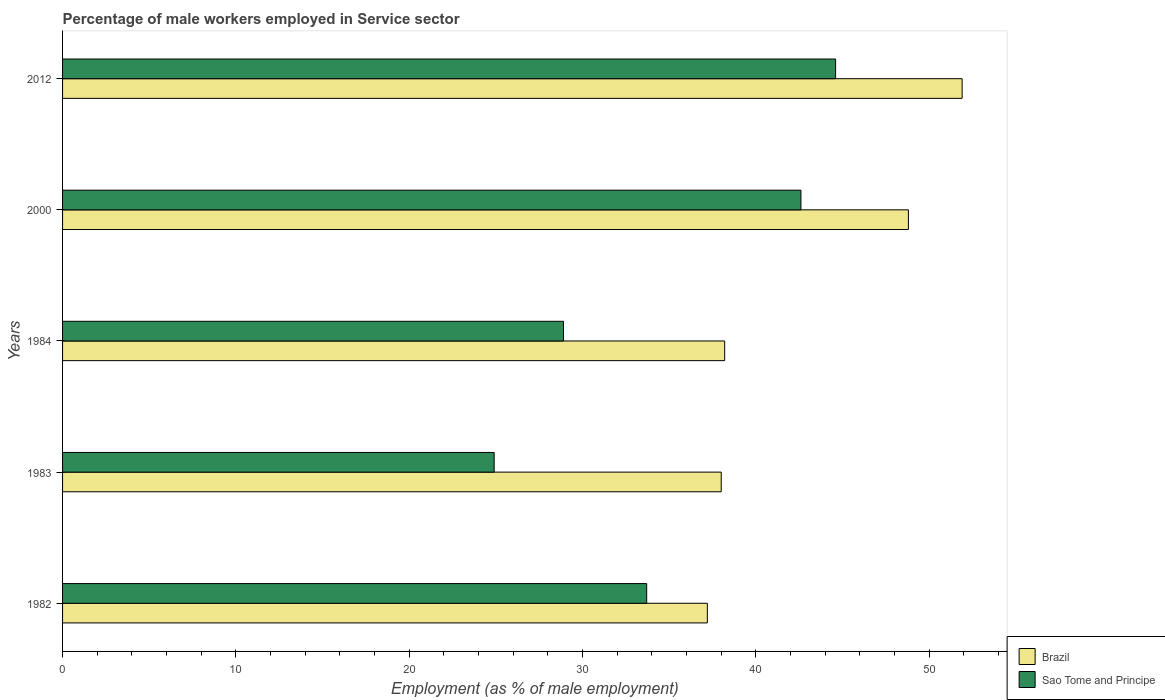Are the number of bars on each tick of the Y-axis equal?
Offer a very short reply. Yes. How many bars are there on the 4th tick from the top?
Your answer should be compact. 2. What is the label of the 1st group of bars from the top?
Provide a short and direct response. 2012. In how many cases, is the number of bars for a given year not equal to the number of legend labels?
Offer a very short reply. 0. What is the percentage of male workers employed in Service sector in Sao Tome and Principe in 2012?
Offer a very short reply. 44.6. Across all years, what is the maximum percentage of male workers employed in Service sector in Brazil?
Your response must be concise. 51.9. Across all years, what is the minimum percentage of male workers employed in Service sector in Sao Tome and Principe?
Provide a succinct answer. 24.9. In which year was the percentage of male workers employed in Service sector in Brazil maximum?
Provide a succinct answer. 2012. What is the total percentage of male workers employed in Service sector in Sao Tome and Principe in the graph?
Provide a short and direct response. 174.7. What is the difference between the percentage of male workers employed in Service sector in Brazil in 1982 and that in 2012?
Your response must be concise. -14.7. What is the difference between the percentage of male workers employed in Service sector in Brazil in 1983 and the percentage of male workers employed in Service sector in Sao Tome and Principe in 2012?
Your answer should be very brief. -6.6. What is the average percentage of male workers employed in Service sector in Sao Tome and Principe per year?
Keep it short and to the point. 34.94. In the year 1984, what is the difference between the percentage of male workers employed in Service sector in Brazil and percentage of male workers employed in Service sector in Sao Tome and Principe?
Give a very brief answer. 9.3. In how many years, is the percentage of male workers employed in Service sector in Sao Tome and Principe greater than 10 %?
Your answer should be compact. 5. What is the ratio of the percentage of male workers employed in Service sector in Brazil in 1984 to that in 2012?
Provide a short and direct response. 0.74. Is the difference between the percentage of male workers employed in Service sector in Brazil in 1984 and 2012 greater than the difference between the percentage of male workers employed in Service sector in Sao Tome and Principe in 1984 and 2012?
Offer a very short reply. Yes. What is the difference between the highest and the second highest percentage of male workers employed in Service sector in Brazil?
Your response must be concise. 3.1. What is the difference between the highest and the lowest percentage of male workers employed in Service sector in Brazil?
Your answer should be compact. 14.7. Is the sum of the percentage of male workers employed in Service sector in Sao Tome and Principe in 1982 and 1983 greater than the maximum percentage of male workers employed in Service sector in Brazil across all years?
Keep it short and to the point. Yes. What does the 1st bar from the top in 2012 represents?
Your answer should be compact. Sao Tome and Principe. What does the 1st bar from the bottom in 1982 represents?
Offer a terse response. Brazil. How many bars are there?
Give a very brief answer. 10. What is the difference between two consecutive major ticks on the X-axis?
Make the answer very short. 10. Does the graph contain grids?
Your answer should be compact. No. How many legend labels are there?
Your response must be concise. 2. What is the title of the graph?
Offer a terse response. Percentage of male workers employed in Service sector. Does "Central African Republic" appear as one of the legend labels in the graph?
Your answer should be very brief. No. What is the label or title of the X-axis?
Your answer should be compact. Employment (as % of male employment). What is the label or title of the Y-axis?
Make the answer very short. Years. What is the Employment (as % of male employment) of Brazil in 1982?
Ensure brevity in your answer.  37.2. What is the Employment (as % of male employment) of Sao Tome and Principe in 1982?
Provide a short and direct response. 33.7. What is the Employment (as % of male employment) in Sao Tome and Principe in 1983?
Provide a short and direct response. 24.9. What is the Employment (as % of male employment) in Brazil in 1984?
Your answer should be compact. 38.2. What is the Employment (as % of male employment) of Sao Tome and Principe in 1984?
Ensure brevity in your answer.  28.9. What is the Employment (as % of male employment) of Brazil in 2000?
Keep it short and to the point. 48.8. What is the Employment (as % of male employment) of Sao Tome and Principe in 2000?
Ensure brevity in your answer.  42.6. What is the Employment (as % of male employment) of Brazil in 2012?
Your response must be concise. 51.9. What is the Employment (as % of male employment) of Sao Tome and Principe in 2012?
Your answer should be compact. 44.6. Across all years, what is the maximum Employment (as % of male employment) of Brazil?
Your answer should be very brief. 51.9. Across all years, what is the maximum Employment (as % of male employment) of Sao Tome and Principe?
Keep it short and to the point. 44.6. Across all years, what is the minimum Employment (as % of male employment) in Brazil?
Ensure brevity in your answer.  37.2. Across all years, what is the minimum Employment (as % of male employment) of Sao Tome and Principe?
Keep it short and to the point. 24.9. What is the total Employment (as % of male employment) in Brazil in the graph?
Ensure brevity in your answer.  214.1. What is the total Employment (as % of male employment) of Sao Tome and Principe in the graph?
Give a very brief answer. 174.7. What is the difference between the Employment (as % of male employment) in Brazil in 1982 and that in 1983?
Keep it short and to the point. -0.8. What is the difference between the Employment (as % of male employment) in Sao Tome and Principe in 1982 and that in 1983?
Give a very brief answer. 8.8. What is the difference between the Employment (as % of male employment) in Brazil in 1982 and that in 1984?
Give a very brief answer. -1. What is the difference between the Employment (as % of male employment) of Brazil in 1982 and that in 2000?
Make the answer very short. -11.6. What is the difference between the Employment (as % of male employment) in Brazil in 1982 and that in 2012?
Ensure brevity in your answer.  -14.7. What is the difference between the Employment (as % of male employment) of Brazil in 1983 and that in 1984?
Give a very brief answer. -0.2. What is the difference between the Employment (as % of male employment) in Sao Tome and Principe in 1983 and that in 2000?
Your response must be concise. -17.7. What is the difference between the Employment (as % of male employment) of Brazil in 1983 and that in 2012?
Offer a very short reply. -13.9. What is the difference between the Employment (as % of male employment) of Sao Tome and Principe in 1983 and that in 2012?
Make the answer very short. -19.7. What is the difference between the Employment (as % of male employment) in Brazil in 1984 and that in 2000?
Your answer should be very brief. -10.6. What is the difference between the Employment (as % of male employment) of Sao Tome and Principe in 1984 and that in 2000?
Provide a short and direct response. -13.7. What is the difference between the Employment (as % of male employment) of Brazil in 1984 and that in 2012?
Give a very brief answer. -13.7. What is the difference between the Employment (as % of male employment) of Sao Tome and Principe in 1984 and that in 2012?
Provide a short and direct response. -15.7. What is the difference between the Employment (as % of male employment) of Brazil in 2000 and that in 2012?
Offer a terse response. -3.1. What is the difference between the Employment (as % of male employment) in Brazil in 1982 and the Employment (as % of male employment) in Sao Tome and Principe in 2012?
Keep it short and to the point. -7.4. What is the difference between the Employment (as % of male employment) in Brazil in 1983 and the Employment (as % of male employment) in Sao Tome and Principe in 1984?
Provide a succinct answer. 9.1. What is the difference between the Employment (as % of male employment) of Brazil in 1983 and the Employment (as % of male employment) of Sao Tome and Principe in 2000?
Offer a very short reply. -4.6. What is the difference between the Employment (as % of male employment) of Brazil in 1984 and the Employment (as % of male employment) of Sao Tome and Principe in 2012?
Give a very brief answer. -6.4. What is the difference between the Employment (as % of male employment) in Brazil in 2000 and the Employment (as % of male employment) in Sao Tome and Principe in 2012?
Your answer should be compact. 4.2. What is the average Employment (as % of male employment) in Brazil per year?
Provide a short and direct response. 42.82. What is the average Employment (as % of male employment) of Sao Tome and Principe per year?
Offer a terse response. 34.94. In the year 1983, what is the difference between the Employment (as % of male employment) of Brazil and Employment (as % of male employment) of Sao Tome and Principe?
Your answer should be compact. 13.1. In the year 2000, what is the difference between the Employment (as % of male employment) in Brazil and Employment (as % of male employment) in Sao Tome and Principe?
Offer a very short reply. 6.2. What is the ratio of the Employment (as % of male employment) of Brazil in 1982 to that in 1983?
Offer a terse response. 0.98. What is the ratio of the Employment (as % of male employment) of Sao Tome and Principe in 1982 to that in 1983?
Offer a terse response. 1.35. What is the ratio of the Employment (as % of male employment) of Brazil in 1982 to that in 1984?
Give a very brief answer. 0.97. What is the ratio of the Employment (as % of male employment) in Sao Tome and Principe in 1982 to that in 1984?
Your answer should be compact. 1.17. What is the ratio of the Employment (as % of male employment) of Brazil in 1982 to that in 2000?
Ensure brevity in your answer.  0.76. What is the ratio of the Employment (as % of male employment) of Sao Tome and Principe in 1982 to that in 2000?
Give a very brief answer. 0.79. What is the ratio of the Employment (as % of male employment) in Brazil in 1982 to that in 2012?
Offer a terse response. 0.72. What is the ratio of the Employment (as % of male employment) of Sao Tome and Principe in 1982 to that in 2012?
Your response must be concise. 0.76. What is the ratio of the Employment (as % of male employment) in Sao Tome and Principe in 1983 to that in 1984?
Provide a succinct answer. 0.86. What is the ratio of the Employment (as % of male employment) of Brazil in 1983 to that in 2000?
Offer a very short reply. 0.78. What is the ratio of the Employment (as % of male employment) of Sao Tome and Principe in 1983 to that in 2000?
Make the answer very short. 0.58. What is the ratio of the Employment (as % of male employment) in Brazil in 1983 to that in 2012?
Your answer should be compact. 0.73. What is the ratio of the Employment (as % of male employment) in Sao Tome and Principe in 1983 to that in 2012?
Provide a short and direct response. 0.56. What is the ratio of the Employment (as % of male employment) in Brazil in 1984 to that in 2000?
Keep it short and to the point. 0.78. What is the ratio of the Employment (as % of male employment) of Sao Tome and Principe in 1984 to that in 2000?
Ensure brevity in your answer.  0.68. What is the ratio of the Employment (as % of male employment) of Brazil in 1984 to that in 2012?
Provide a short and direct response. 0.74. What is the ratio of the Employment (as % of male employment) in Sao Tome and Principe in 1984 to that in 2012?
Your answer should be very brief. 0.65. What is the ratio of the Employment (as % of male employment) in Brazil in 2000 to that in 2012?
Offer a very short reply. 0.94. What is the ratio of the Employment (as % of male employment) in Sao Tome and Principe in 2000 to that in 2012?
Your response must be concise. 0.96. What is the difference between the highest and the second highest Employment (as % of male employment) in Brazil?
Give a very brief answer. 3.1. What is the difference between the highest and the lowest Employment (as % of male employment) of Sao Tome and Principe?
Your response must be concise. 19.7. 